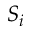Convert formula to latex. <formula><loc_0><loc_0><loc_500><loc_500>S _ { i }</formula> 